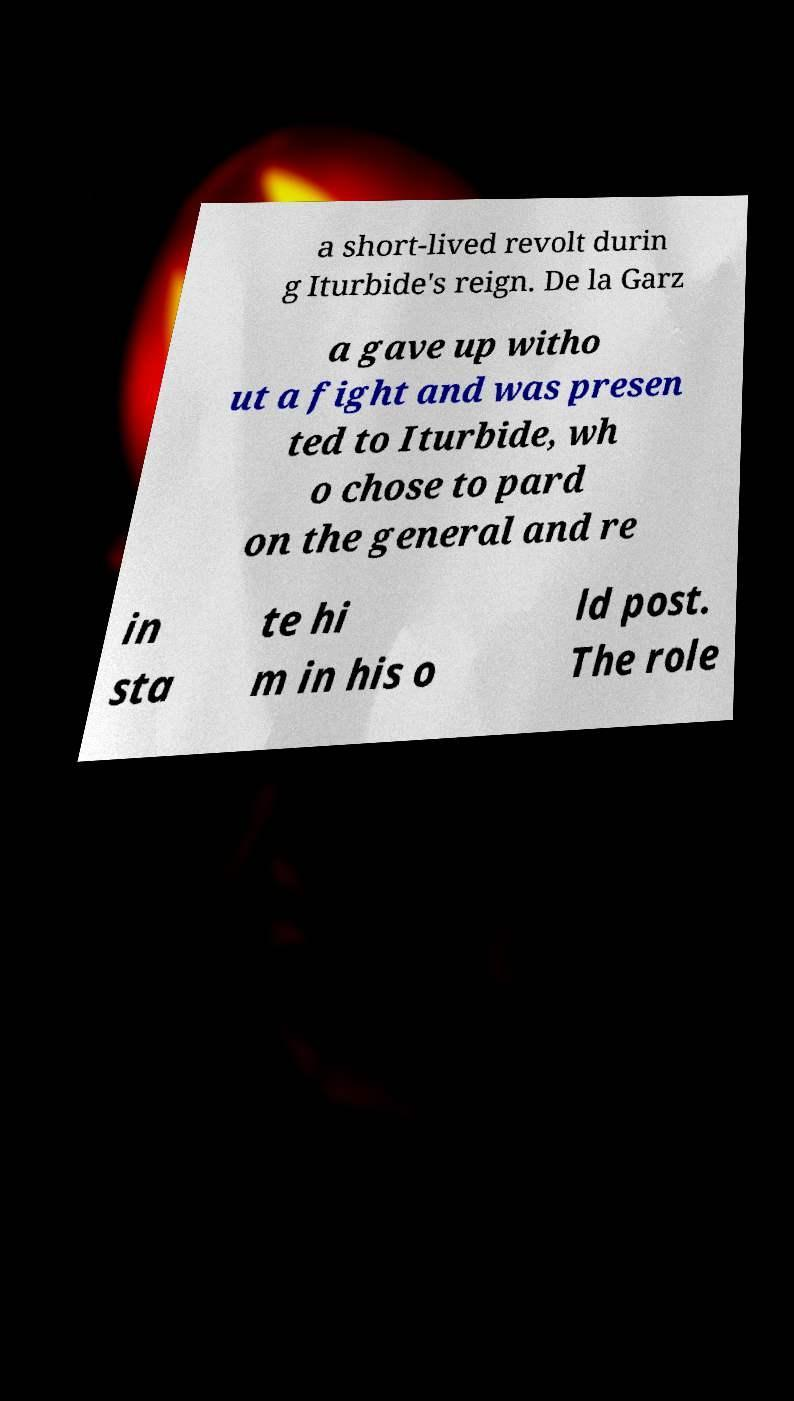Can you accurately transcribe the text from the provided image for me? a short-lived revolt durin g Iturbide's reign. De la Garz a gave up witho ut a fight and was presen ted to Iturbide, wh o chose to pard on the general and re in sta te hi m in his o ld post. The role 